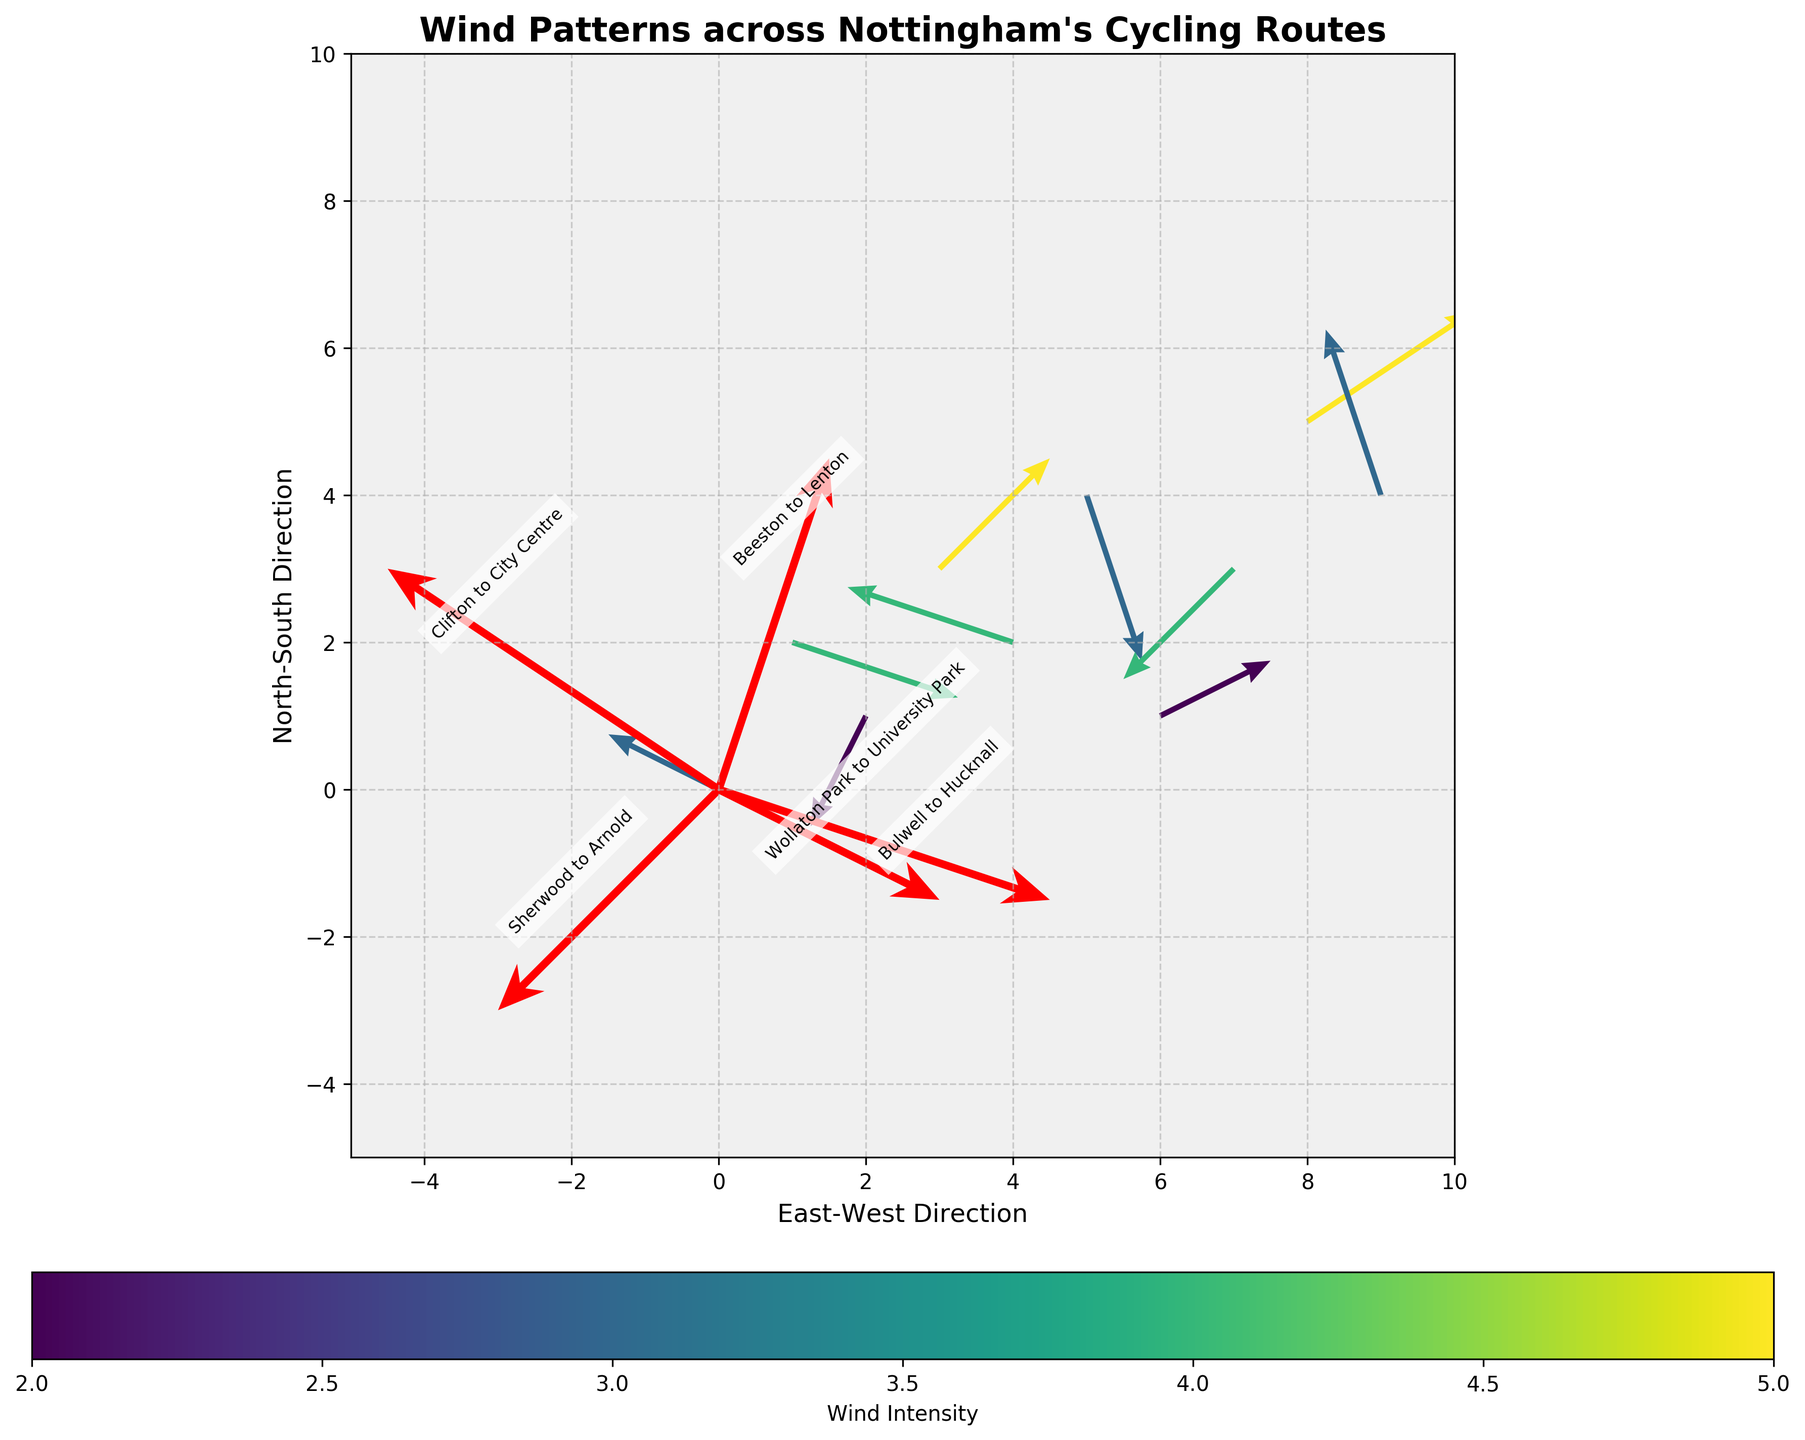What's the title of the figure? The title is usually located at the top center of the figure. By looking in that area, you can see the title "Wind Patterns across Nottingham's Cycling Routes" in bold.
Answer: Wind Patterns across Nottingham's Cycling Routes How many locations are annotated with names in the figure? By visually identifying the annotations that have names on them, there are five named locations: Wollaton Park, Clifton, Beeston, Sherwood, and Bulwell.
Answer: 5 Which route shows the highest wind intensity? In the annotations, the color-coded wind bar shows intensity. The location with the highest wind intensity is noted by the color closest to the maximum on the colormap. Looking at the annotations, Clifton to City Centre has the highest intensity, represented by 5.
Answer: Clifton to City Centre What directions do the wind patterns mostly follow in Wollaton Park to University Park? By looking at the direction of the arrowhead for this specific annotation, you can observe that it mostly follows a westward and slightly downward direction indicated by the vector (-2, 1).
Answer: Westward and slightly downward Which numeric data point shows the least wind intensity? By examining the color coding or the value connected to each vector, you identify the lightest color or the smallest value. The vector at coordinates (2, 1) with an intensity of 2 has the least wind intensity.
Answer: (2, 1) How does the wind pattern compare between the numeric data point at (8, 5) and the route from Bulwell to Hucknall? First, identify the direction and intensity of both vectors. The vector at (8, 5) has (3, 2) with an intensity of 5, and the Bulwell to Hucknall vector has (3, -1) with an intensity of 3. They both have an eastward component but differ in the north-south component and intensity.
Answer: (8, 5) is stronger and more northeast, while Bulwell to Hucknall is less intense and somewhat southeast What is the average wind intensity among the named locations? Sum the wind intensities of all the annotated named locations and divide by the number of named locations: (4 + 5 + 3 + 4 + 3) / 5 = 19 / 5 = 3.8.
Answer: 3.8 Which numeric data point has an eastward and southward wind pattern? By examining the direction of the arrows, the vector exhibiting a positive u (eastward) and a negative v (southward) component matches these criteria. The coordinate (5, 4) with the vector (1, -3) fits this description.
Answer: (5, 4) Is the wind intensity from Beeston to Lenton equal to the wind intensity from Wollaton Park to University Park? The wind intensity for Beeston to Lenton is 3, and for Wollaton Park to University Park, it is 4. Comparing these values, they are not equal.
Answer: No 